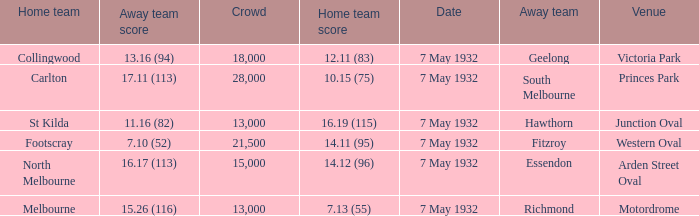Which home team has a Away team of hawthorn? St Kilda. 